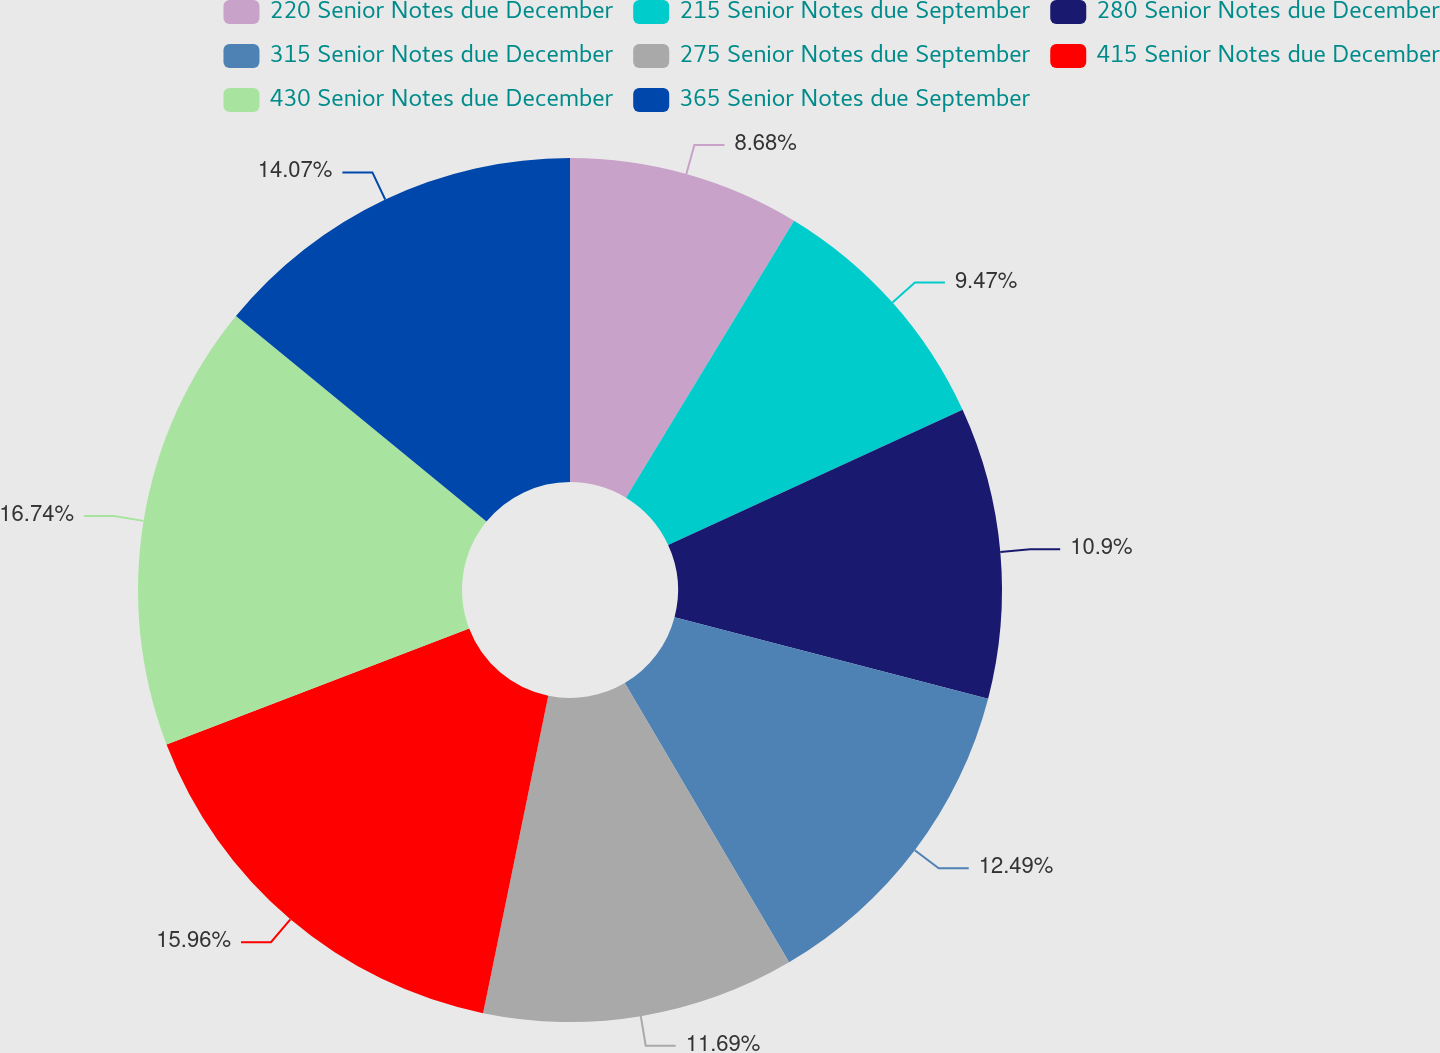Convert chart to OTSL. <chart><loc_0><loc_0><loc_500><loc_500><pie_chart><fcel>220 Senior Notes due December<fcel>215 Senior Notes due September<fcel>280 Senior Notes due December<fcel>315 Senior Notes due December<fcel>275 Senior Notes due September<fcel>415 Senior Notes due December<fcel>430 Senior Notes due December<fcel>365 Senior Notes due September<nl><fcel>8.68%<fcel>9.47%<fcel>10.9%<fcel>12.49%<fcel>11.69%<fcel>15.96%<fcel>16.75%<fcel>14.07%<nl></chart> 